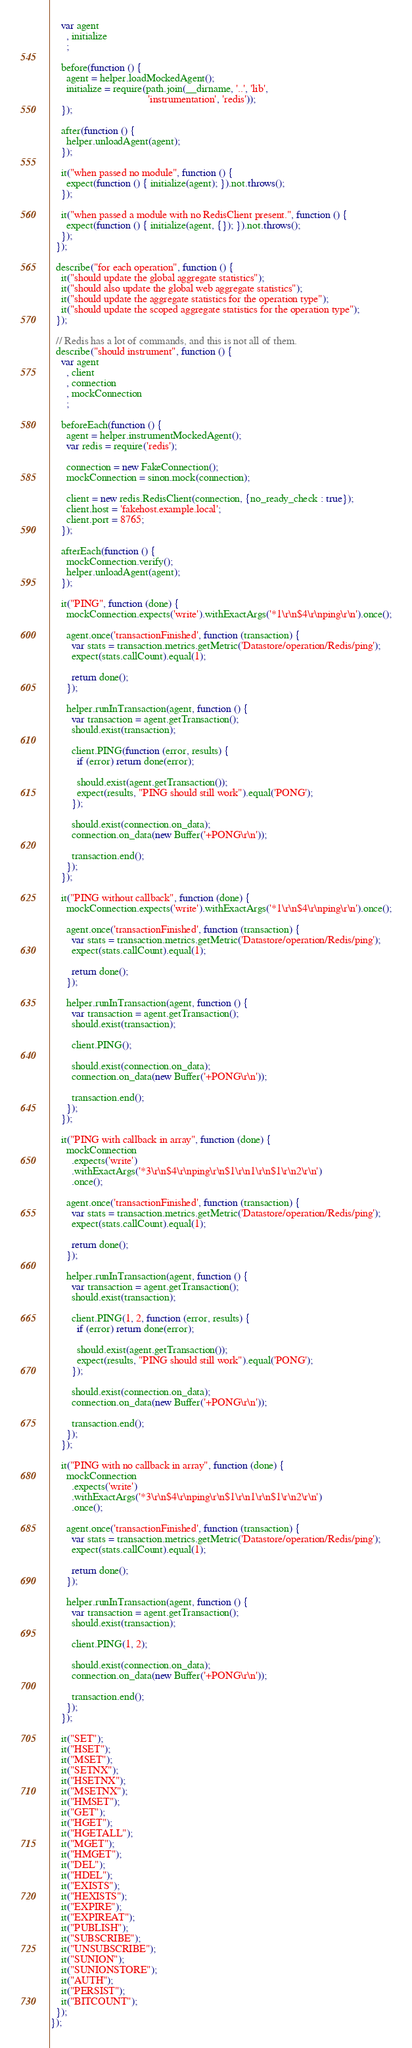Convert code to text. <code><loc_0><loc_0><loc_500><loc_500><_JavaScript_>    var agent
      , initialize
      ;

    before(function () {
      agent = helper.loadMockedAgent();
      initialize = require(path.join(__dirname, '..', 'lib',
                                     'instrumentation', 'redis'));
    });

    after(function () {
      helper.unloadAgent(agent);
    });

    it("when passed no module", function () {
      expect(function () { initialize(agent); }).not.throws();
    });

    it("when passed a module with no RedisClient present.", function () {
      expect(function () { initialize(agent, {}); }).not.throws();
    });
  });

  describe("for each operation", function () {
    it("should update the global aggregate statistics");
    it("should also update the global web aggregate statistics");
    it("should update the aggregate statistics for the operation type");
    it("should update the scoped aggregate statistics for the operation type");
  });

  // Redis has a lot of commands, and this is not all of them.
  describe("should instrument", function () {
    var agent
      , client
      , connection
      , mockConnection
      ;

    beforeEach(function () {
      agent = helper.instrumentMockedAgent();
      var redis = require('redis');

      connection = new FakeConnection();
      mockConnection = sinon.mock(connection);

      client = new redis.RedisClient(connection, {no_ready_check : true});
      client.host = 'fakehost.example.local';
      client.port = 8765;
    });

    afterEach(function () {
      mockConnection.verify();
      helper.unloadAgent(agent);
    });

    it("PING", function (done) {
      mockConnection.expects('write').withExactArgs('*1\r\n$4\r\nping\r\n').once();

      agent.once('transactionFinished', function (transaction) {
        var stats = transaction.metrics.getMetric('Datastore/operation/Redis/ping');
        expect(stats.callCount).equal(1);

        return done();
      });

      helper.runInTransaction(agent, function () {
        var transaction = agent.getTransaction();
        should.exist(transaction);

        client.PING(function (error, results) {
          if (error) return done(error);

          should.exist(agent.getTransaction());
          expect(results, "PING should still work").equal('PONG');
        });

        should.exist(connection.on_data);
        connection.on_data(new Buffer('+PONG\r\n'));

        transaction.end();
      });
    });

    it("PING without callback", function (done) {
      mockConnection.expects('write').withExactArgs('*1\r\n$4\r\nping\r\n').once();

      agent.once('transactionFinished', function (transaction) {
        var stats = transaction.metrics.getMetric('Datastore/operation/Redis/ping');
        expect(stats.callCount).equal(1);

        return done();
      });

      helper.runInTransaction(agent, function () {
        var transaction = agent.getTransaction();
        should.exist(transaction);

        client.PING();

        should.exist(connection.on_data);
        connection.on_data(new Buffer('+PONG\r\n'));

        transaction.end();
      });
    });

    it("PING with callback in array", function (done) {
      mockConnection
        .expects('write')
        .withExactArgs('*3\r\n$4\r\nping\r\n$1\r\n1\r\n$1\r\n2\r\n')
        .once();

      agent.once('transactionFinished', function (transaction) {
        var stats = transaction.metrics.getMetric('Datastore/operation/Redis/ping');
        expect(stats.callCount).equal(1);

        return done();
      });

      helper.runInTransaction(agent, function () {
        var transaction = agent.getTransaction();
        should.exist(transaction);

        client.PING(1, 2, function (error, results) {
          if (error) return done(error);

          should.exist(agent.getTransaction());
          expect(results, "PING should still work").equal('PONG');
        });

        should.exist(connection.on_data);
        connection.on_data(new Buffer('+PONG\r\n'));

        transaction.end();
      });
    });

    it("PING with no callback in array", function (done) {
      mockConnection
        .expects('write')
        .withExactArgs('*3\r\n$4\r\nping\r\n$1\r\n1\r\n$1\r\n2\r\n')
        .once();

      agent.once('transactionFinished', function (transaction) {
        var stats = transaction.metrics.getMetric('Datastore/operation/Redis/ping');
        expect(stats.callCount).equal(1);

        return done();
      });

      helper.runInTransaction(agent, function () {
        var transaction = agent.getTransaction();
        should.exist(transaction);

        client.PING(1, 2);

        should.exist(connection.on_data);
        connection.on_data(new Buffer('+PONG\r\n'));

        transaction.end();
      });
    });

    it("SET");
    it("HSET");
    it("MSET");
    it("SETNX");
    it("HSETNX");
    it("MSETNX");
    it("HMSET");
    it("GET");
    it("HGET");
    it("HGETALL");
    it("MGET");
    it("HMGET");
    it("DEL");
    it("HDEL");
    it("EXISTS");
    it("HEXISTS");
    it("EXPIRE");
    it("EXPIREAT");
    it("PUBLISH");
    it("SUBSCRIBE");
    it("UNSUBSCRIBE");
    it("SUNION");
    it("SUNIONSTORE");
    it("AUTH");
    it("PERSIST");
    it("BITCOUNT");
  });
});
</code> 